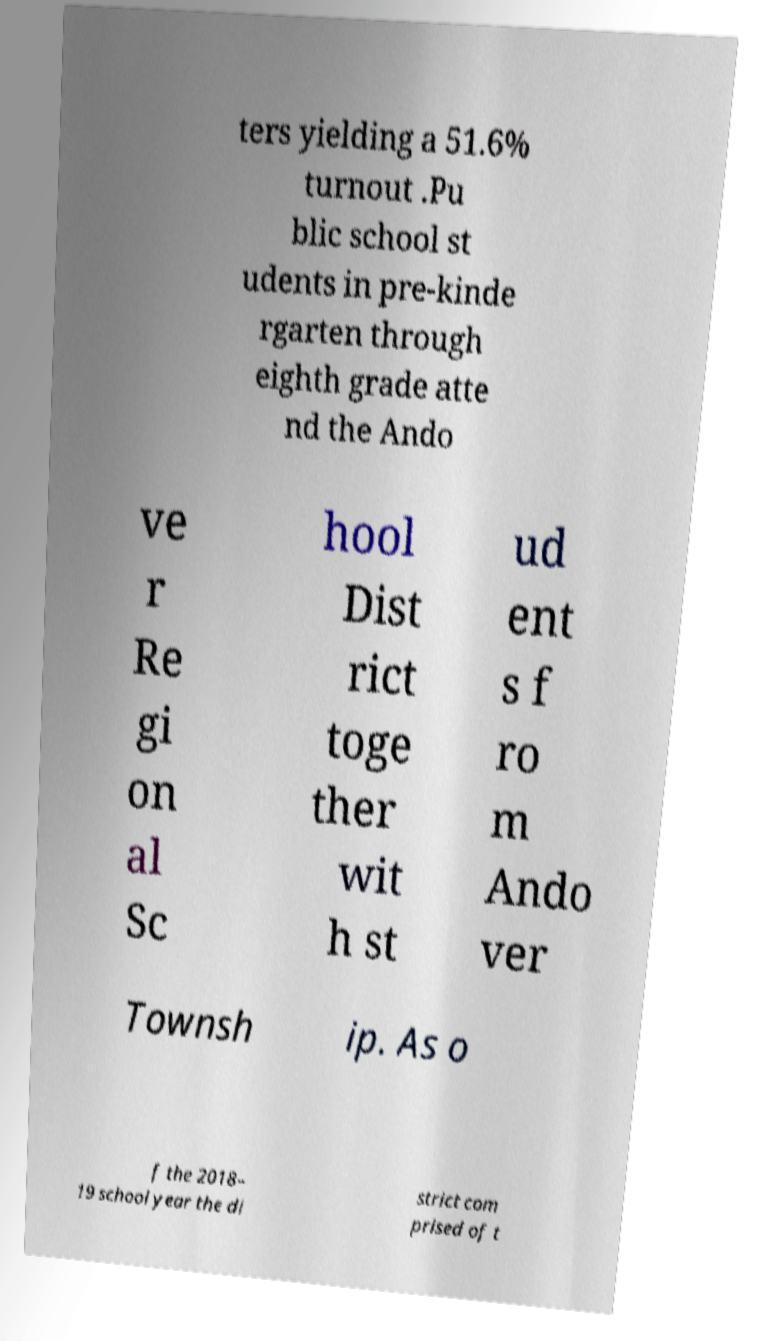What messages or text are displayed in this image? I need them in a readable, typed format. ters yielding a 51.6% turnout .Pu blic school st udents in pre-kinde rgarten through eighth grade atte nd the Ando ve r Re gi on al Sc hool Dist rict toge ther wit h st ud ent s f ro m Ando ver Townsh ip. As o f the 2018– 19 school year the di strict com prised of t 